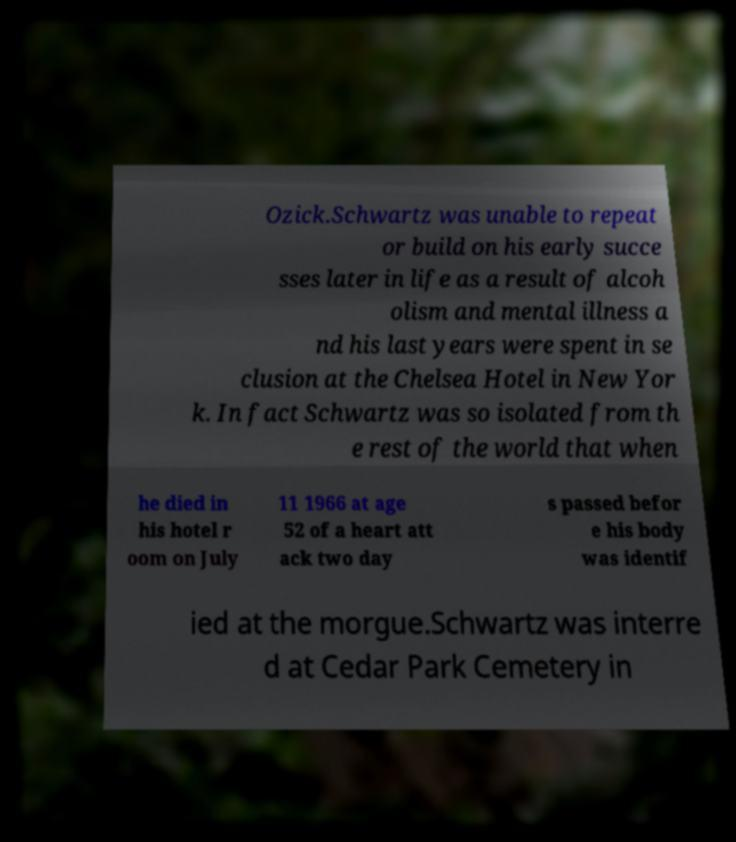Could you extract and type out the text from this image? Ozick.Schwartz was unable to repeat or build on his early succe sses later in life as a result of alcoh olism and mental illness a nd his last years were spent in se clusion at the Chelsea Hotel in New Yor k. In fact Schwartz was so isolated from th e rest of the world that when he died in his hotel r oom on July 11 1966 at age 52 of a heart att ack two day s passed befor e his body was identif ied at the morgue.Schwartz was interre d at Cedar Park Cemetery in 